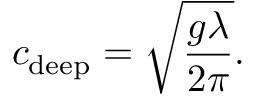Convert formula to latex. <formula><loc_0><loc_0><loc_500><loc_500>c _ { d e e p } = { \sqrt { \frac { g \lambda } { 2 \pi } } } .</formula> 